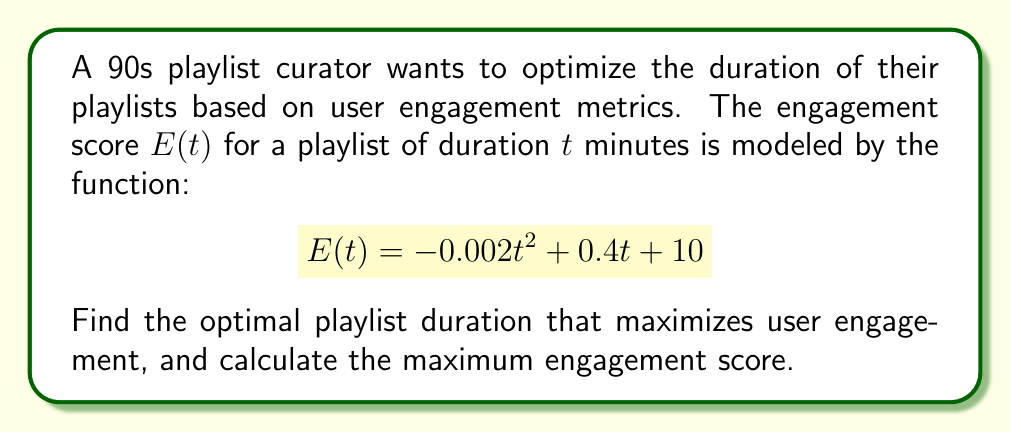What is the answer to this math problem? To find the optimal playlist duration that maximizes user engagement, we need to find the maximum of the function $E(t)$. This can be done by following these steps:

1. Find the derivative of $E(t)$ with respect to $t$:
   $$E'(t) = -0.004t + 0.4$$

2. Set the derivative equal to zero and solve for $t$:
   $$-0.004t + 0.4 = 0$$
   $$-0.004t = -0.4$$
   $$t = 100$$

3. Verify that this critical point is a maximum by checking the second derivative:
   $$E''(t) = -0.004$$
   Since $E''(t)$ is negative, the critical point is indeed a maximum.

4. Calculate the maximum engagement score by plugging $t = 100$ into the original function:
   $$E(100) = -0.002(100)^2 + 0.4(100) + 10$$
   $$= -20 + 40 + 10$$
   $$= 30$$

Therefore, the optimal playlist duration is 100 minutes, and the maximum engagement score is 30.
Answer: Optimal playlist duration: 100 minutes
Maximum engagement score: 30 